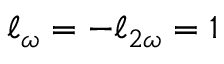Convert formula to latex. <formula><loc_0><loc_0><loc_500><loc_500>\ell _ { \omega } = - \ell _ { 2 \omega } = 1</formula> 